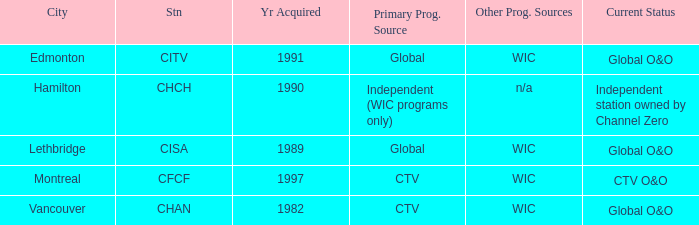How any were gained as the chan 1.0. 